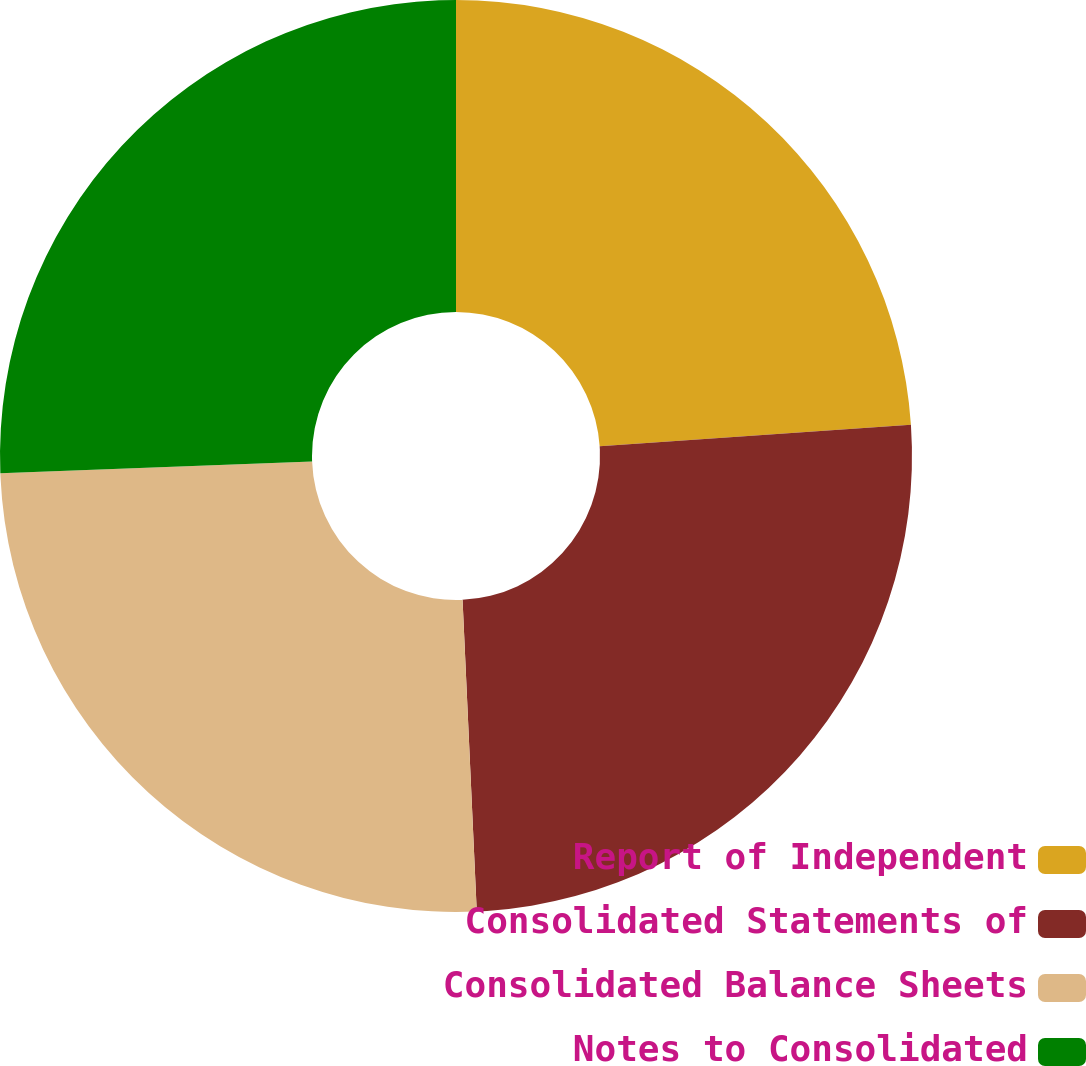Convert chart to OTSL. <chart><loc_0><loc_0><loc_500><loc_500><pie_chart><fcel>Report of Independent<fcel>Consolidated Statements of<fcel>Consolidated Balance Sheets<fcel>Notes to Consolidated<nl><fcel>23.91%<fcel>25.36%<fcel>25.12%<fcel>25.6%<nl></chart> 